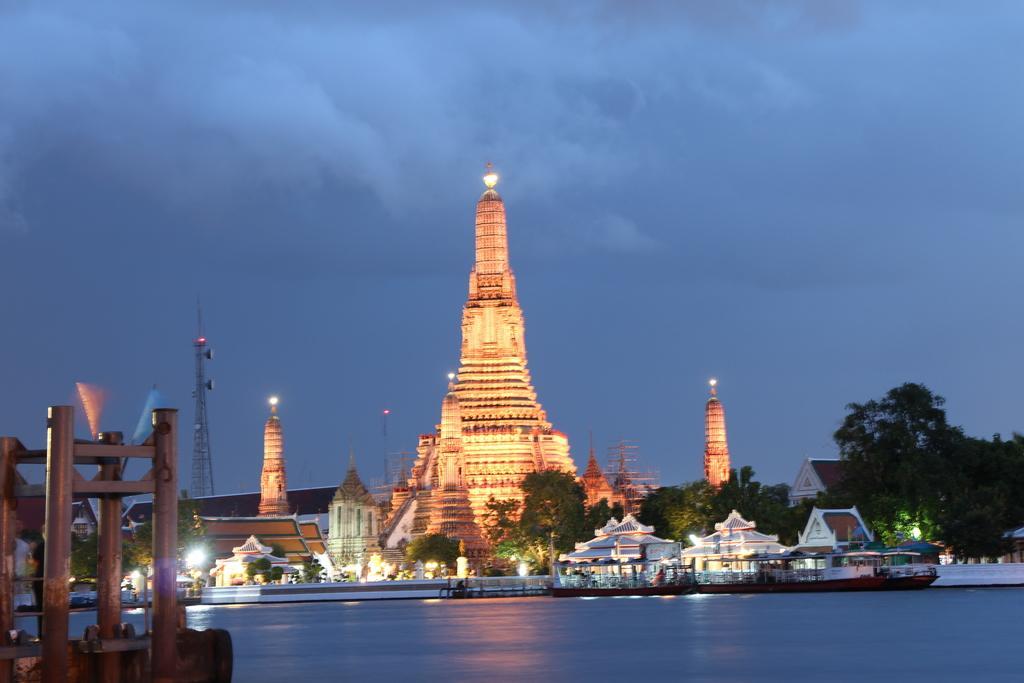Could you give a brief overview of what you see in this image? In this image, I can see a temple with lights, buildings, trees and a tower. There are boats on the water. At the bottom left side of the image, I can see iron rods. In the background, there is the sky. 